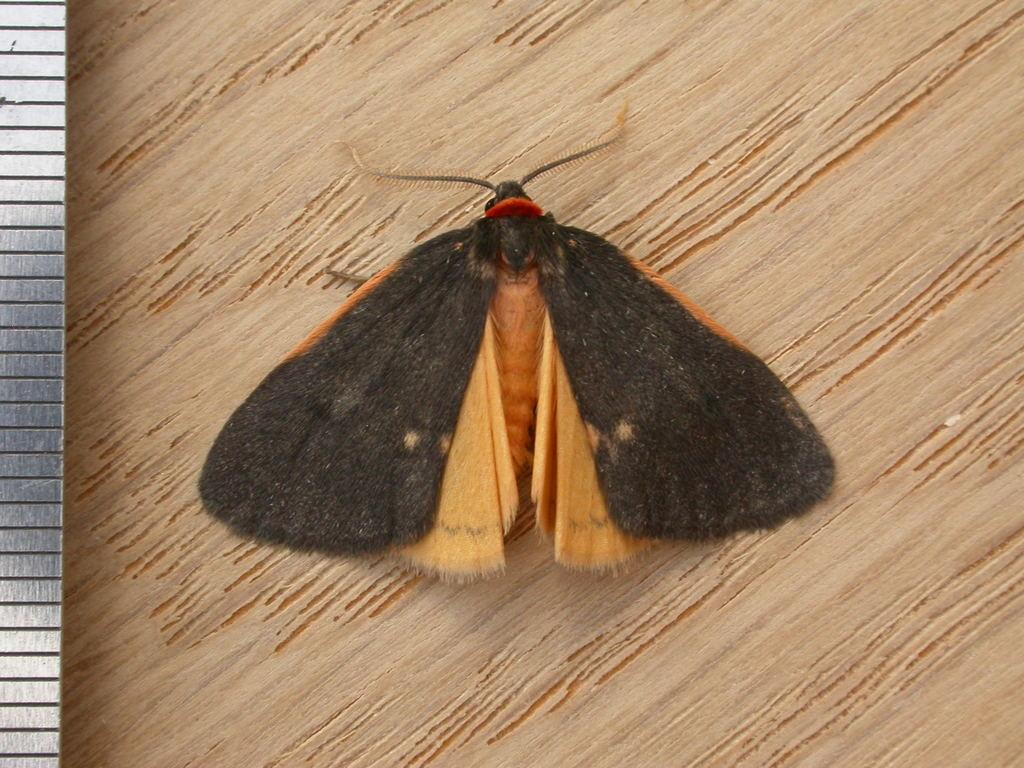What type of creature is in the image? There is a butterfly in the image. What colors can be seen on the butterfly? The butterfly has black and brown colors. What is the butterfly resting on in the image? The butterfly is on a brown surface. Can you see a kitty playing with a vessel in the background of the image? There is no kitty or vessel present in the image; it only features a butterfly on a brown surface. 